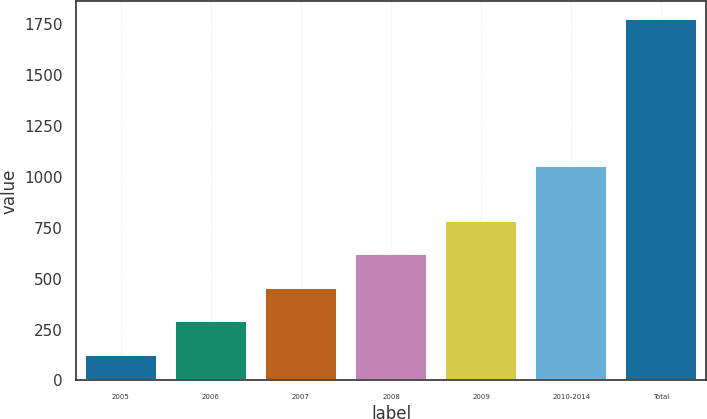Convert chart to OTSL. <chart><loc_0><loc_0><loc_500><loc_500><bar_chart><fcel>2005<fcel>2006<fcel>2007<fcel>2008<fcel>2009<fcel>2010-2014<fcel>Total<nl><fcel>125<fcel>289.7<fcel>454.4<fcel>619.1<fcel>783.8<fcel>1052<fcel>1772<nl></chart> 